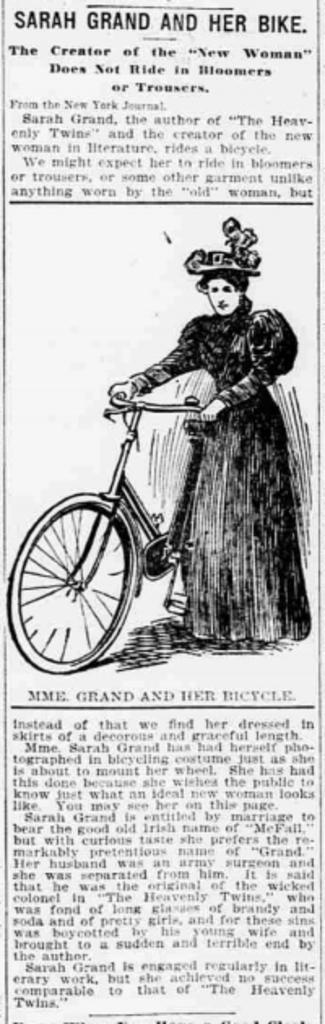Please provide a concise description of this image. In this image there is a poster having some text and painting. On the poster there is some text. Middle of the image there is a painting of a woman standing and she is holding a bicycle. She is wearing a cap. 